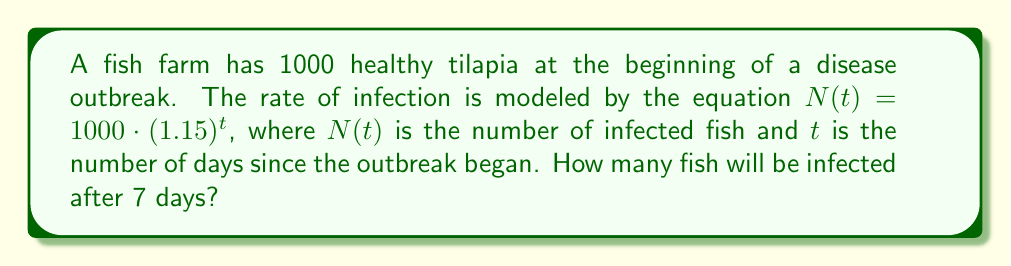Teach me how to tackle this problem. To solve this problem, we need to follow these steps:

1. Identify the given information:
   - Initial number of healthy fish: 1000
   - Rate of infection model: $N(t) = 1000 \cdot (1.15)^t$
   - Time period: 7 days

2. Substitute the value of $t$ (7 days) into the equation:
   $N(7) = 1000 \cdot (1.15)^7$

3. Calculate the result:
   $N(7) = 1000 \cdot (1.15)^7$
   $N(7) = 1000 \cdot 2.6600$
   $N(7) = 2660$

4. Round the result to the nearest whole number, as we can't have a fractional number of fish:
   $N(7) \approx 2660$ infected fish

Therefore, after 7 days, approximately 2660 fish will be infected.
Answer: 2660 fish 